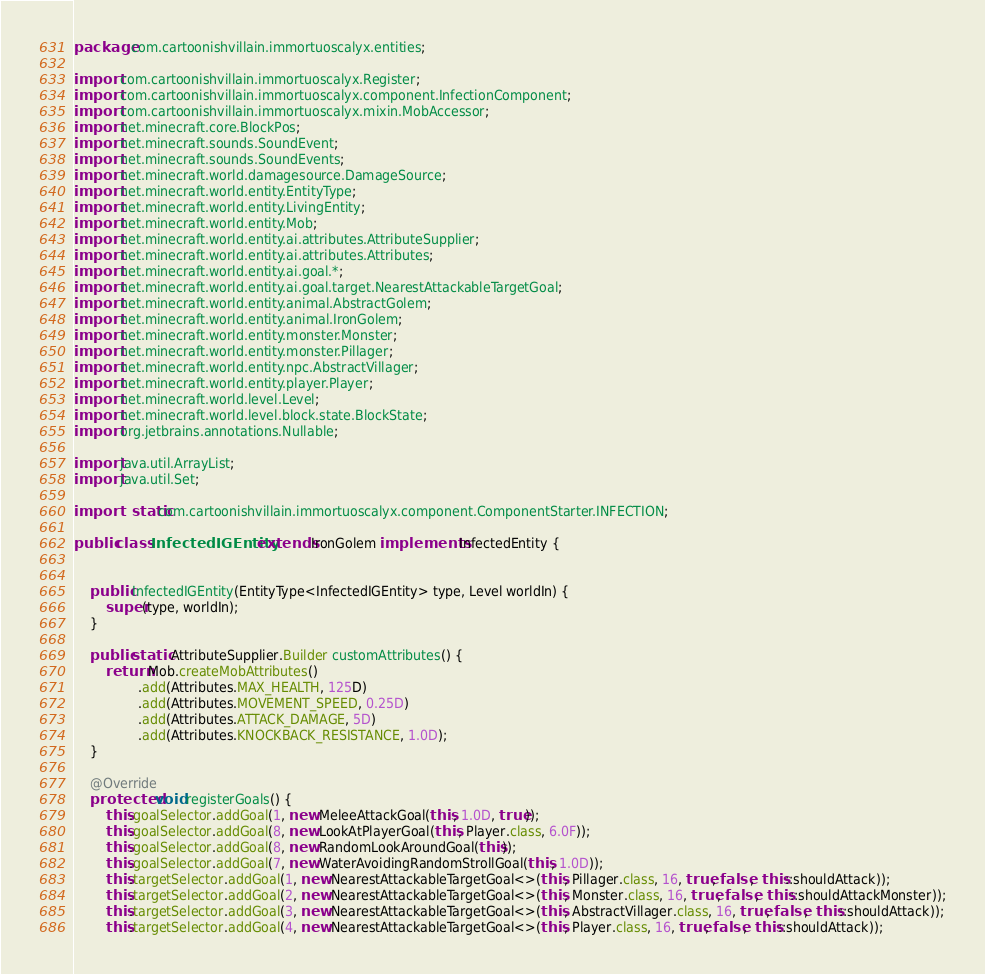<code> <loc_0><loc_0><loc_500><loc_500><_Java_>package com.cartoonishvillain.immortuoscalyx.entities;

import com.cartoonishvillain.immortuoscalyx.Register;
import com.cartoonishvillain.immortuoscalyx.component.InfectionComponent;
import com.cartoonishvillain.immortuoscalyx.mixin.MobAccessor;
import net.minecraft.core.BlockPos;
import net.minecraft.sounds.SoundEvent;
import net.minecraft.sounds.SoundEvents;
import net.minecraft.world.damagesource.DamageSource;
import net.minecraft.world.entity.EntityType;
import net.minecraft.world.entity.LivingEntity;
import net.minecraft.world.entity.Mob;
import net.minecraft.world.entity.ai.attributes.AttributeSupplier;
import net.minecraft.world.entity.ai.attributes.Attributes;
import net.minecraft.world.entity.ai.goal.*;
import net.minecraft.world.entity.ai.goal.target.NearestAttackableTargetGoal;
import net.minecraft.world.entity.animal.AbstractGolem;
import net.minecraft.world.entity.animal.IronGolem;
import net.minecraft.world.entity.monster.Monster;
import net.minecraft.world.entity.monster.Pillager;
import net.minecraft.world.entity.npc.AbstractVillager;
import net.minecraft.world.entity.player.Player;
import net.minecraft.world.level.Level;
import net.minecraft.world.level.block.state.BlockState;
import org.jetbrains.annotations.Nullable;

import java.util.ArrayList;
import java.util.Set;

import static com.cartoonishvillain.immortuoscalyx.component.ComponentStarter.INFECTION;

public class InfectedIGEntity extends IronGolem implements InfectedEntity {


    public InfectedIGEntity(EntityType<InfectedIGEntity> type, Level worldIn) {
        super(type, worldIn);
    }

    public static AttributeSupplier.Builder customAttributes() {
        return Mob.createMobAttributes()
                .add(Attributes.MAX_HEALTH, 125D)
                .add(Attributes.MOVEMENT_SPEED, 0.25D)
                .add(Attributes.ATTACK_DAMAGE, 5D)
                .add(Attributes.KNOCKBACK_RESISTANCE, 1.0D);
    }

    @Override
    protected void registerGoals() {
        this.goalSelector.addGoal(1, new MeleeAttackGoal(this, 1.0D, true));
        this.goalSelector.addGoal(8, new LookAtPlayerGoal(this, Player.class, 6.0F));
        this.goalSelector.addGoal(8, new RandomLookAroundGoal(this));
        this.goalSelector.addGoal(7, new WaterAvoidingRandomStrollGoal(this, 1.0D));
        this.targetSelector.addGoal(1, new NearestAttackableTargetGoal<>(this, Pillager.class, 16, true, false,  this::shouldAttack));
        this.targetSelector.addGoal(2, new NearestAttackableTargetGoal<>(this, Monster.class, 16, true, false,  this::shouldAttackMonster));
        this.targetSelector.addGoal(3, new NearestAttackableTargetGoal<>(this, AbstractVillager.class, 16, true, false,  this::shouldAttack));
        this.targetSelector.addGoal(4, new NearestAttackableTargetGoal<>(this, Player.class, 16, true, false,  this::shouldAttack));</code> 